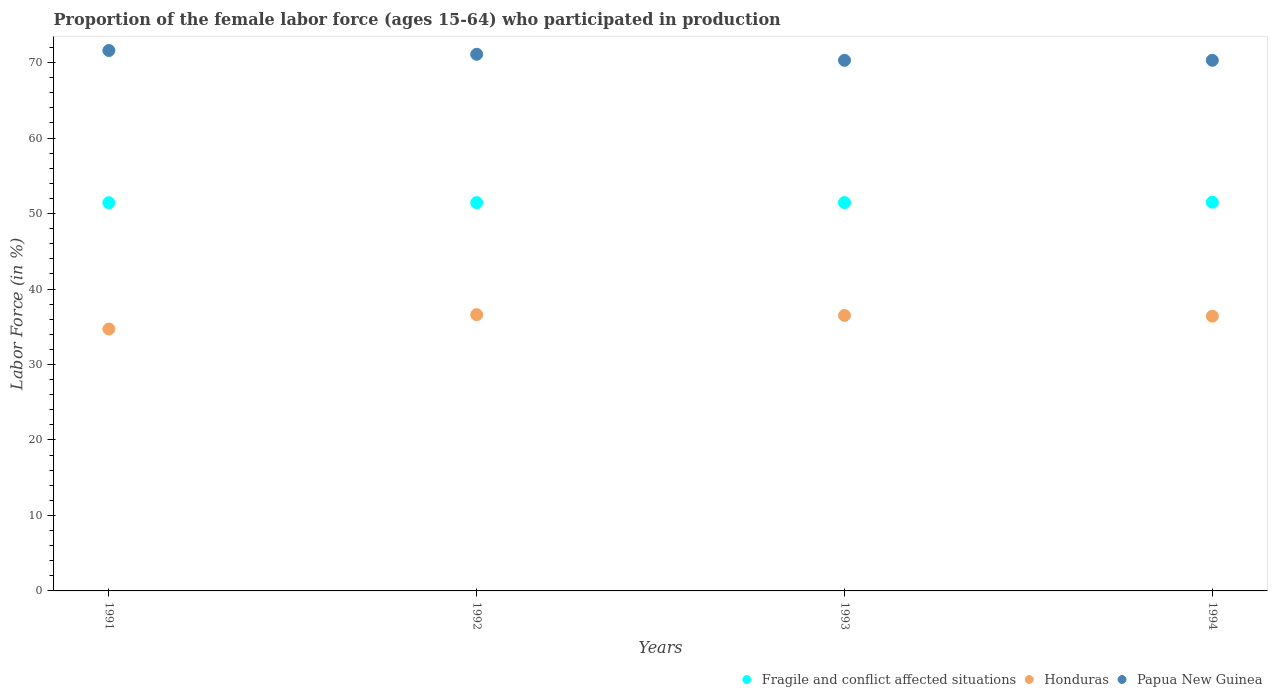How many different coloured dotlines are there?
Your answer should be compact. 3. What is the proportion of the female labor force who participated in production in Honduras in 1991?
Give a very brief answer. 34.7. Across all years, what is the maximum proportion of the female labor force who participated in production in Fragile and conflict affected situations?
Offer a terse response. 51.5. Across all years, what is the minimum proportion of the female labor force who participated in production in Honduras?
Offer a very short reply. 34.7. In which year was the proportion of the female labor force who participated in production in Honduras minimum?
Your answer should be compact. 1991. What is the total proportion of the female labor force who participated in production in Fragile and conflict affected situations in the graph?
Give a very brief answer. 205.83. What is the difference between the proportion of the female labor force who participated in production in Honduras in 1992 and that in 1993?
Provide a short and direct response. 0.1. What is the difference between the proportion of the female labor force who participated in production in Fragile and conflict affected situations in 1991 and the proportion of the female labor force who participated in production in Papua New Guinea in 1992?
Give a very brief answer. -19.66. What is the average proportion of the female labor force who participated in production in Fragile and conflict affected situations per year?
Provide a succinct answer. 51.46. In the year 1991, what is the difference between the proportion of the female labor force who participated in production in Papua New Guinea and proportion of the female labor force who participated in production in Fragile and conflict affected situations?
Your response must be concise. 20.16. In how many years, is the proportion of the female labor force who participated in production in Papua New Guinea greater than 48 %?
Provide a succinct answer. 4. What is the ratio of the proportion of the female labor force who participated in production in Honduras in 1991 to that in 1994?
Offer a very short reply. 0.95. Is the difference between the proportion of the female labor force who participated in production in Papua New Guinea in 1991 and 1992 greater than the difference between the proportion of the female labor force who participated in production in Fragile and conflict affected situations in 1991 and 1992?
Your answer should be very brief. Yes. What is the difference between the highest and the lowest proportion of the female labor force who participated in production in Papua New Guinea?
Your response must be concise. 1.3. Does the proportion of the female labor force who participated in production in Honduras monotonically increase over the years?
Your response must be concise. No. How many dotlines are there?
Offer a very short reply. 3. How many years are there in the graph?
Make the answer very short. 4. What is the difference between two consecutive major ticks on the Y-axis?
Make the answer very short. 10. Does the graph contain any zero values?
Your response must be concise. No. How many legend labels are there?
Give a very brief answer. 3. How are the legend labels stacked?
Ensure brevity in your answer.  Horizontal. What is the title of the graph?
Your answer should be compact. Proportion of the female labor force (ages 15-64) who participated in production. Does "Marshall Islands" appear as one of the legend labels in the graph?
Make the answer very short. No. What is the label or title of the Y-axis?
Provide a succinct answer. Labor Force (in %). What is the Labor Force (in %) of Fragile and conflict affected situations in 1991?
Offer a very short reply. 51.44. What is the Labor Force (in %) of Honduras in 1991?
Provide a short and direct response. 34.7. What is the Labor Force (in %) in Papua New Guinea in 1991?
Your response must be concise. 71.6. What is the Labor Force (in %) of Fragile and conflict affected situations in 1992?
Your answer should be very brief. 51.44. What is the Labor Force (in %) in Honduras in 1992?
Ensure brevity in your answer.  36.6. What is the Labor Force (in %) in Papua New Guinea in 1992?
Give a very brief answer. 71.1. What is the Labor Force (in %) of Fragile and conflict affected situations in 1993?
Your answer should be very brief. 51.45. What is the Labor Force (in %) of Honduras in 1993?
Your answer should be very brief. 36.5. What is the Labor Force (in %) of Papua New Guinea in 1993?
Your response must be concise. 70.3. What is the Labor Force (in %) of Fragile and conflict affected situations in 1994?
Offer a very short reply. 51.5. What is the Labor Force (in %) of Honduras in 1994?
Give a very brief answer. 36.4. What is the Labor Force (in %) of Papua New Guinea in 1994?
Provide a succinct answer. 70.3. Across all years, what is the maximum Labor Force (in %) in Fragile and conflict affected situations?
Ensure brevity in your answer.  51.5. Across all years, what is the maximum Labor Force (in %) of Honduras?
Your response must be concise. 36.6. Across all years, what is the maximum Labor Force (in %) of Papua New Guinea?
Make the answer very short. 71.6. Across all years, what is the minimum Labor Force (in %) in Fragile and conflict affected situations?
Keep it short and to the point. 51.44. Across all years, what is the minimum Labor Force (in %) in Honduras?
Offer a very short reply. 34.7. Across all years, what is the minimum Labor Force (in %) of Papua New Guinea?
Offer a very short reply. 70.3. What is the total Labor Force (in %) in Fragile and conflict affected situations in the graph?
Give a very brief answer. 205.83. What is the total Labor Force (in %) in Honduras in the graph?
Your response must be concise. 144.2. What is the total Labor Force (in %) of Papua New Guinea in the graph?
Provide a succinct answer. 283.3. What is the difference between the Labor Force (in %) of Fragile and conflict affected situations in 1991 and that in 1992?
Offer a terse response. -0.01. What is the difference between the Labor Force (in %) in Papua New Guinea in 1991 and that in 1992?
Provide a short and direct response. 0.5. What is the difference between the Labor Force (in %) of Fragile and conflict affected situations in 1991 and that in 1993?
Keep it short and to the point. -0.02. What is the difference between the Labor Force (in %) in Fragile and conflict affected situations in 1991 and that in 1994?
Your response must be concise. -0.06. What is the difference between the Labor Force (in %) in Fragile and conflict affected situations in 1992 and that in 1993?
Keep it short and to the point. -0.01. What is the difference between the Labor Force (in %) of Honduras in 1992 and that in 1993?
Give a very brief answer. 0.1. What is the difference between the Labor Force (in %) of Papua New Guinea in 1992 and that in 1993?
Your answer should be compact. 0.8. What is the difference between the Labor Force (in %) in Fragile and conflict affected situations in 1992 and that in 1994?
Offer a very short reply. -0.06. What is the difference between the Labor Force (in %) in Honduras in 1992 and that in 1994?
Keep it short and to the point. 0.2. What is the difference between the Labor Force (in %) of Papua New Guinea in 1992 and that in 1994?
Give a very brief answer. 0.8. What is the difference between the Labor Force (in %) of Fragile and conflict affected situations in 1993 and that in 1994?
Offer a terse response. -0.05. What is the difference between the Labor Force (in %) of Papua New Guinea in 1993 and that in 1994?
Your response must be concise. 0. What is the difference between the Labor Force (in %) in Fragile and conflict affected situations in 1991 and the Labor Force (in %) in Honduras in 1992?
Your answer should be compact. 14.84. What is the difference between the Labor Force (in %) in Fragile and conflict affected situations in 1991 and the Labor Force (in %) in Papua New Guinea in 1992?
Give a very brief answer. -19.66. What is the difference between the Labor Force (in %) in Honduras in 1991 and the Labor Force (in %) in Papua New Guinea in 1992?
Offer a very short reply. -36.4. What is the difference between the Labor Force (in %) in Fragile and conflict affected situations in 1991 and the Labor Force (in %) in Honduras in 1993?
Give a very brief answer. 14.94. What is the difference between the Labor Force (in %) in Fragile and conflict affected situations in 1991 and the Labor Force (in %) in Papua New Guinea in 1993?
Keep it short and to the point. -18.86. What is the difference between the Labor Force (in %) in Honduras in 1991 and the Labor Force (in %) in Papua New Guinea in 1993?
Give a very brief answer. -35.6. What is the difference between the Labor Force (in %) of Fragile and conflict affected situations in 1991 and the Labor Force (in %) of Honduras in 1994?
Offer a very short reply. 15.04. What is the difference between the Labor Force (in %) of Fragile and conflict affected situations in 1991 and the Labor Force (in %) of Papua New Guinea in 1994?
Offer a terse response. -18.86. What is the difference between the Labor Force (in %) of Honduras in 1991 and the Labor Force (in %) of Papua New Guinea in 1994?
Provide a succinct answer. -35.6. What is the difference between the Labor Force (in %) of Fragile and conflict affected situations in 1992 and the Labor Force (in %) of Honduras in 1993?
Your answer should be very brief. 14.94. What is the difference between the Labor Force (in %) in Fragile and conflict affected situations in 1992 and the Labor Force (in %) in Papua New Guinea in 1993?
Keep it short and to the point. -18.86. What is the difference between the Labor Force (in %) of Honduras in 1992 and the Labor Force (in %) of Papua New Guinea in 1993?
Offer a terse response. -33.7. What is the difference between the Labor Force (in %) in Fragile and conflict affected situations in 1992 and the Labor Force (in %) in Honduras in 1994?
Provide a short and direct response. 15.04. What is the difference between the Labor Force (in %) in Fragile and conflict affected situations in 1992 and the Labor Force (in %) in Papua New Guinea in 1994?
Your answer should be very brief. -18.86. What is the difference between the Labor Force (in %) of Honduras in 1992 and the Labor Force (in %) of Papua New Guinea in 1994?
Offer a very short reply. -33.7. What is the difference between the Labor Force (in %) in Fragile and conflict affected situations in 1993 and the Labor Force (in %) in Honduras in 1994?
Keep it short and to the point. 15.05. What is the difference between the Labor Force (in %) of Fragile and conflict affected situations in 1993 and the Labor Force (in %) of Papua New Guinea in 1994?
Your answer should be compact. -18.85. What is the difference between the Labor Force (in %) in Honduras in 1993 and the Labor Force (in %) in Papua New Guinea in 1994?
Make the answer very short. -33.8. What is the average Labor Force (in %) of Fragile and conflict affected situations per year?
Make the answer very short. 51.46. What is the average Labor Force (in %) in Honduras per year?
Your response must be concise. 36.05. What is the average Labor Force (in %) in Papua New Guinea per year?
Offer a terse response. 70.83. In the year 1991, what is the difference between the Labor Force (in %) in Fragile and conflict affected situations and Labor Force (in %) in Honduras?
Your answer should be compact. 16.74. In the year 1991, what is the difference between the Labor Force (in %) of Fragile and conflict affected situations and Labor Force (in %) of Papua New Guinea?
Keep it short and to the point. -20.16. In the year 1991, what is the difference between the Labor Force (in %) in Honduras and Labor Force (in %) in Papua New Guinea?
Keep it short and to the point. -36.9. In the year 1992, what is the difference between the Labor Force (in %) in Fragile and conflict affected situations and Labor Force (in %) in Honduras?
Offer a terse response. 14.84. In the year 1992, what is the difference between the Labor Force (in %) of Fragile and conflict affected situations and Labor Force (in %) of Papua New Guinea?
Provide a short and direct response. -19.66. In the year 1992, what is the difference between the Labor Force (in %) of Honduras and Labor Force (in %) of Papua New Guinea?
Offer a terse response. -34.5. In the year 1993, what is the difference between the Labor Force (in %) of Fragile and conflict affected situations and Labor Force (in %) of Honduras?
Provide a short and direct response. 14.95. In the year 1993, what is the difference between the Labor Force (in %) of Fragile and conflict affected situations and Labor Force (in %) of Papua New Guinea?
Make the answer very short. -18.85. In the year 1993, what is the difference between the Labor Force (in %) of Honduras and Labor Force (in %) of Papua New Guinea?
Offer a terse response. -33.8. In the year 1994, what is the difference between the Labor Force (in %) of Fragile and conflict affected situations and Labor Force (in %) of Honduras?
Provide a short and direct response. 15.1. In the year 1994, what is the difference between the Labor Force (in %) of Fragile and conflict affected situations and Labor Force (in %) of Papua New Guinea?
Offer a very short reply. -18.8. In the year 1994, what is the difference between the Labor Force (in %) of Honduras and Labor Force (in %) of Papua New Guinea?
Keep it short and to the point. -33.9. What is the ratio of the Labor Force (in %) of Honduras in 1991 to that in 1992?
Ensure brevity in your answer.  0.95. What is the ratio of the Labor Force (in %) in Papua New Guinea in 1991 to that in 1992?
Your response must be concise. 1.01. What is the ratio of the Labor Force (in %) in Honduras in 1991 to that in 1993?
Make the answer very short. 0.95. What is the ratio of the Labor Force (in %) in Papua New Guinea in 1991 to that in 1993?
Ensure brevity in your answer.  1.02. What is the ratio of the Labor Force (in %) of Honduras in 1991 to that in 1994?
Ensure brevity in your answer.  0.95. What is the ratio of the Labor Force (in %) in Papua New Guinea in 1991 to that in 1994?
Offer a terse response. 1.02. What is the ratio of the Labor Force (in %) in Fragile and conflict affected situations in 1992 to that in 1993?
Ensure brevity in your answer.  1. What is the ratio of the Labor Force (in %) in Papua New Guinea in 1992 to that in 1993?
Make the answer very short. 1.01. What is the ratio of the Labor Force (in %) in Fragile and conflict affected situations in 1992 to that in 1994?
Your answer should be compact. 1. What is the ratio of the Labor Force (in %) in Honduras in 1992 to that in 1994?
Offer a terse response. 1.01. What is the ratio of the Labor Force (in %) in Papua New Guinea in 1992 to that in 1994?
Offer a very short reply. 1.01. What is the ratio of the Labor Force (in %) in Fragile and conflict affected situations in 1993 to that in 1994?
Provide a short and direct response. 1. What is the ratio of the Labor Force (in %) of Honduras in 1993 to that in 1994?
Offer a terse response. 1. What is the difference between the highest and the second highest Labor Force (in %) of Fragile and conflict affected situations?
Keep it short and to the point. 0.05. What is the difference between the highest and the lowest Labor Force (in %) in Fragile and conflict affected situations?
Give a very brief answer. 0.06. What is the difference between the highest and the lowest Labor Force (in %) of Papua New Guinea?
Provide a short and direct response. 1.3. 